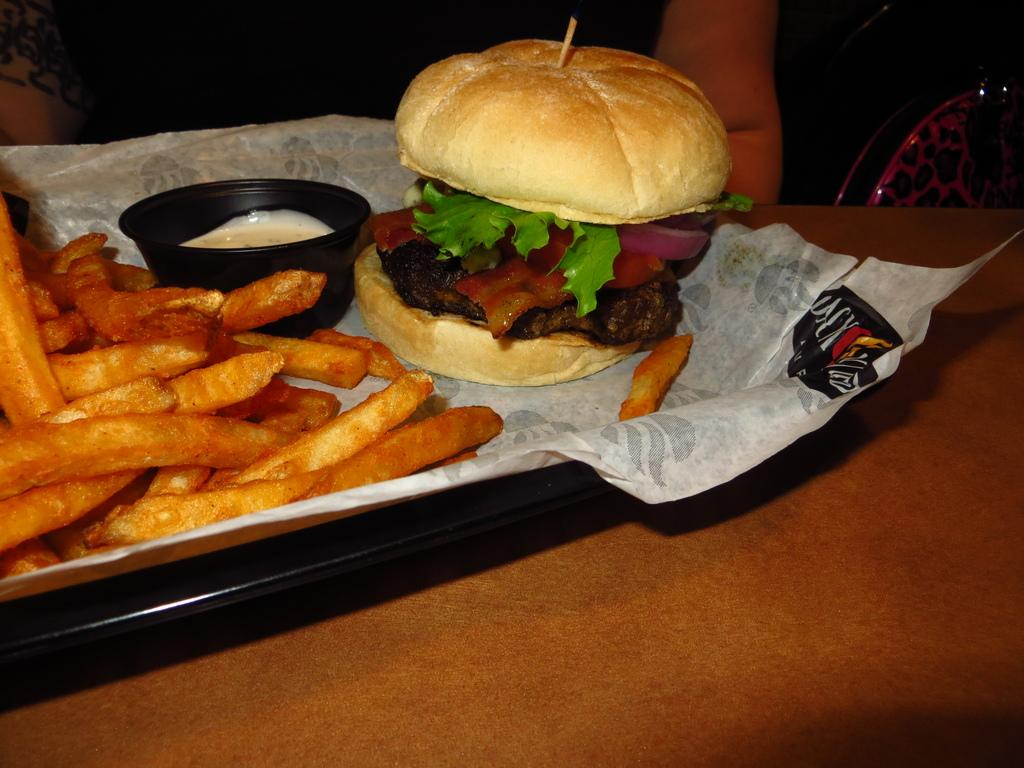What piece of furniture is present in the image? There is a table in the image. What is placed on the table? There is a plate on the table. What can be found on the plate? There are food items on the plate. Can you see any fish being offered on the plate in the image? There is no fish present on the plate in the image. 